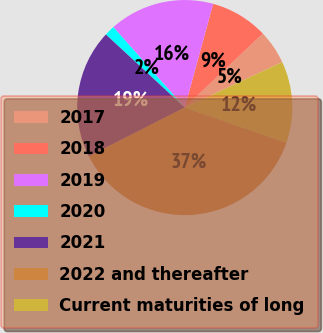<chart> <loc_0><loc_0><loc_500><loc_500><pie_chart><fcel>2017<fcel>2018<fcel>2019<fcel>2020<fcel>2021<fcel>2022 and thereafter<fcel>Current maturities of long<nl><fcel>5.12%<fcel>8.68%<fcel>15.81%<fcel>1.55%<fcel>19.38%<fcel>37.21%<fcel>12.25%<nl></chart> 